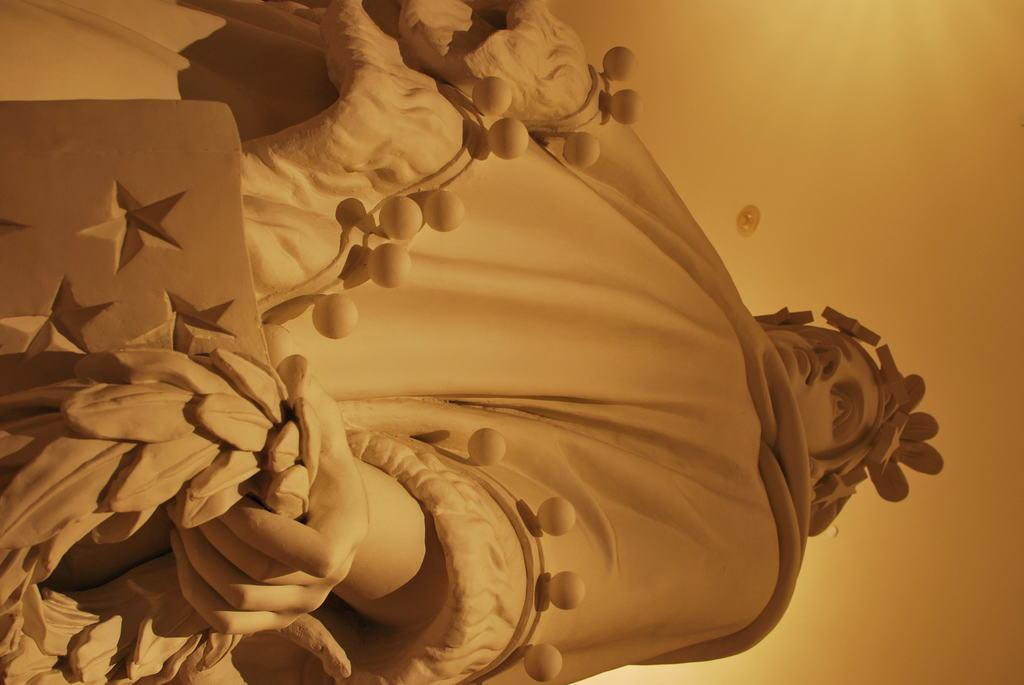What is the main subject of the image? The main subject of the image is a human statue. What is the human statue doing in the image? The human statue is holding some objects in the image. What type of cream is being used by the giants in the image? There are no giants or cream present in the image; it features a human statue holding some objects. 